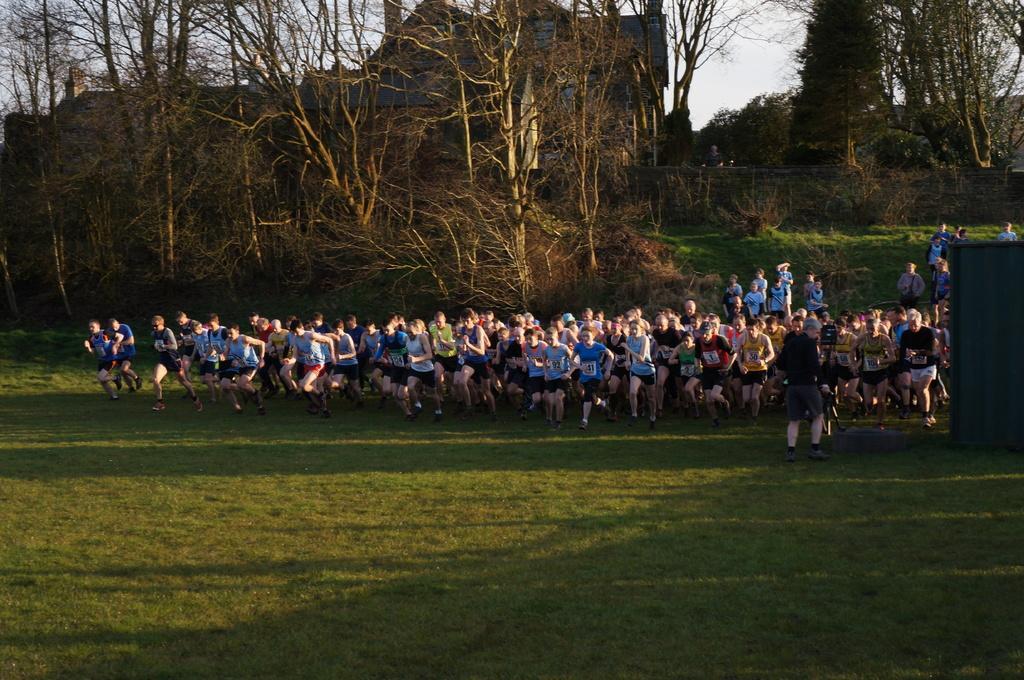In one or two sentences, can you explain what this image depicts? In the center of the image there are people running. At the bottom of the image there is grass. In the background of the image there are trees. 